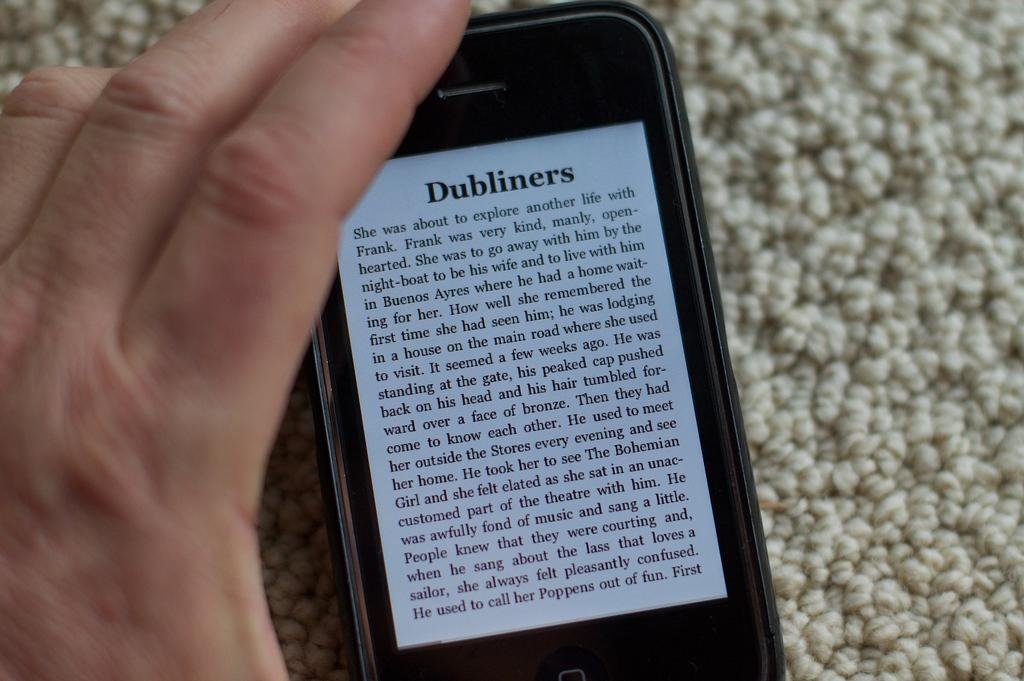<image>
Relay a brief, clear account of the picture shown. Dubliners displayed on a black rectangular cellphone with a white screen. 